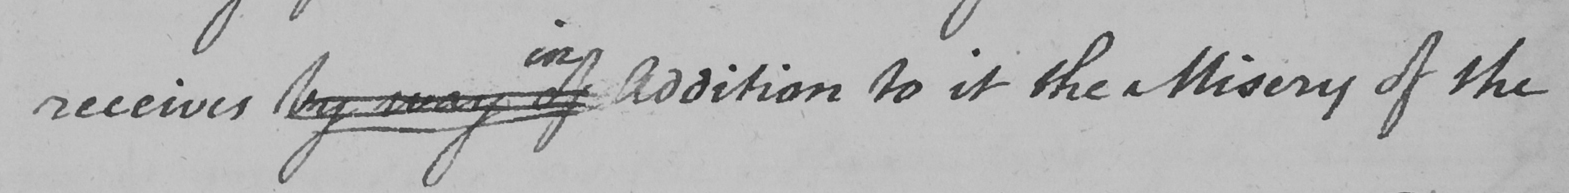Can you read and transcribe this handwriting? receives by way of Addition to it the Misery of the 